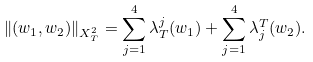Convert formula to latex. <formula><loc_0><loc_0><loc_500><loc_500>\| ( w _ { 1 } , w _ { 2 } ) \| _ { X ^ { 2 } _ { T } } = \sum _ { j = 1 } ^ { 4 } \lambda _ { T } ^ { j } ( w _ { 1 } ) + \sum _ { j = 1 } ^ { 4 } \lambda _ { j } ^ { T } ( w _ { 2 } ) .</formula> 